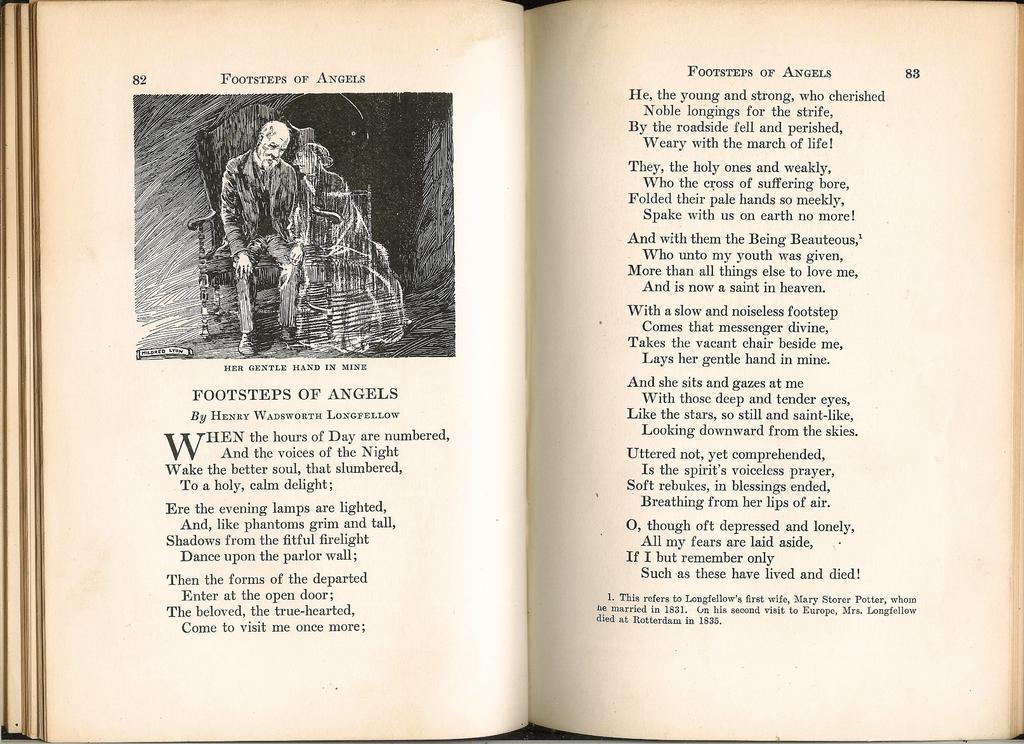What page number is shown on the right?
Your response must be concise. 83. What does the illustration depict?
Keep it short and to the point. Her gentle hand in mine. 